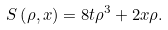<formula> <loc_0><loc_0><loc_500><loc_500>S \left ( \rho , x \right ) = 8 t \rho ^ { 3 } + 2 x \rho .</formula> 